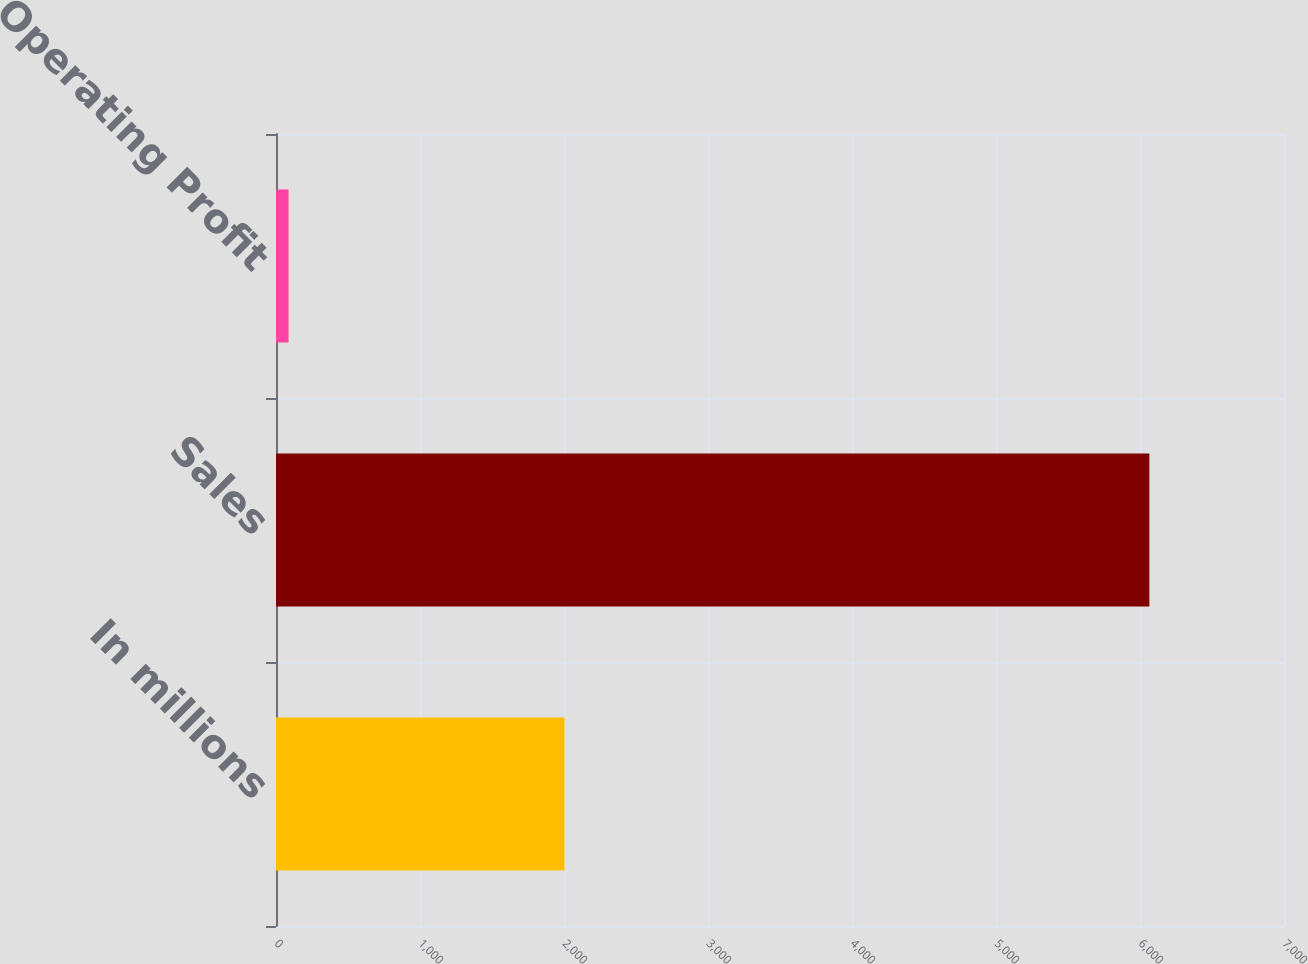Convert chart. <chart><loc_0><loc_0><loc_500><loc_500><bar_chart><fcel>In millions<fcel>Sales<fcel>Operating Profit<nl><fcel>2004<fcel>6065<fcel>87<nl></chart> 